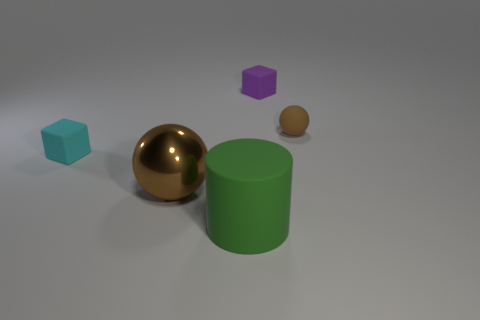Can you describe the sizes of the objects relative to each other? Certainly! In the image, we see a collection of geometric shapes: the large green cylinder is the tallest object. The gold sphere is medium-sized and larger than the brown sphere. The purple cube is the smallest item, and the teal cube is slightly larger than the purple one but smaller than the spheres and cylinder. 